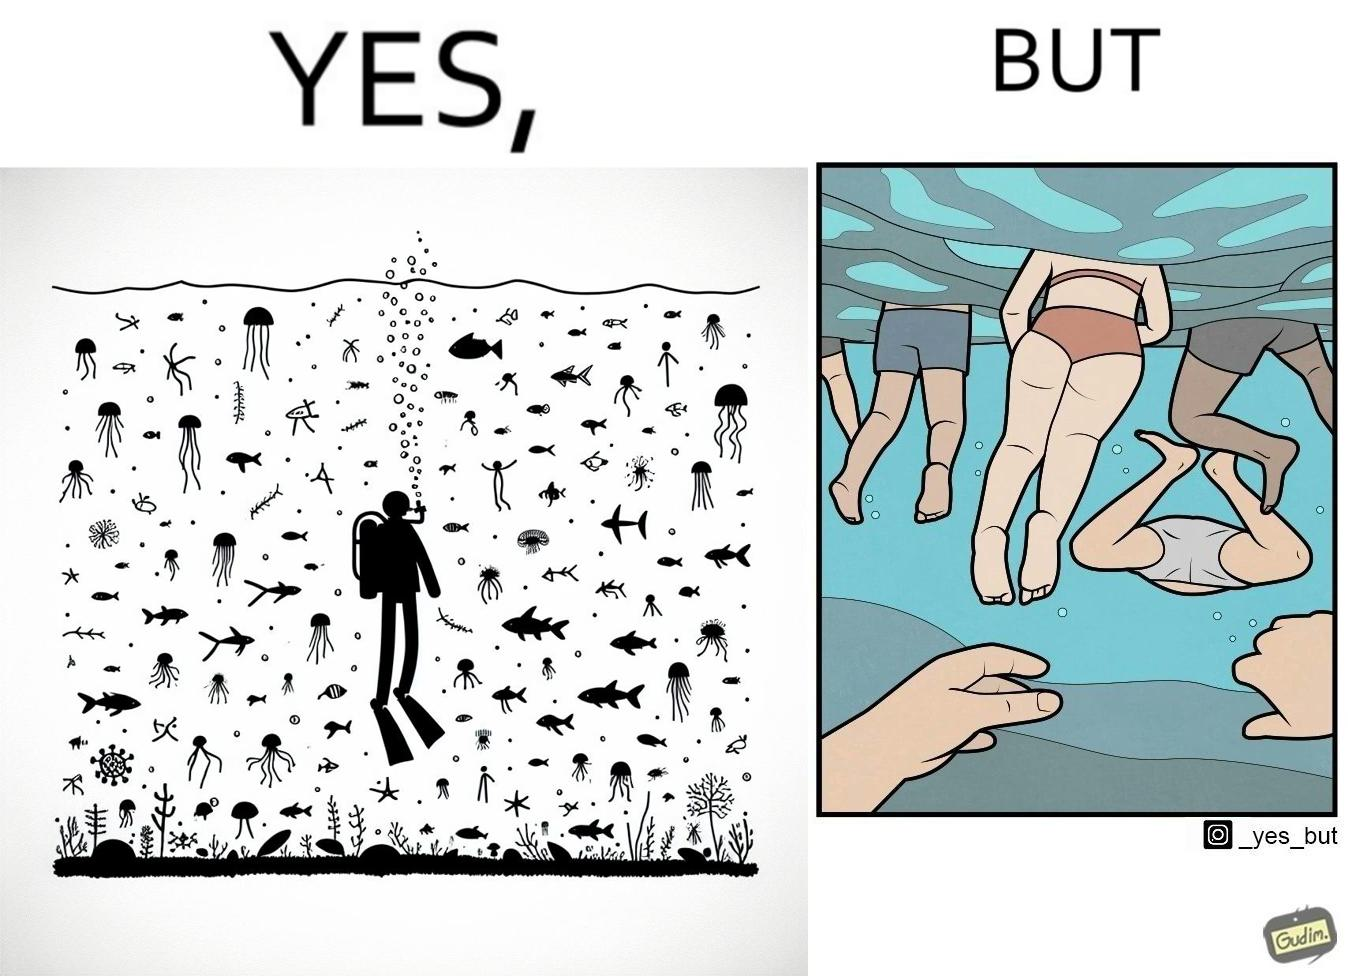What is shown in this image? The image is ironic, because some people like to enjoy watching the biodiversity under water but they are not able to explore this due to excess crowd in such places where people like to play, swim etc. in water 